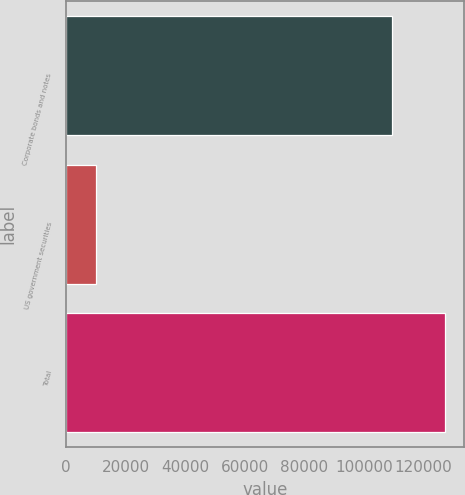Convert chart. <chart><loc_0><loc_0><loc_500><loc_500><bar_chart><fcel>Corporate bonds and notes<fcel>US government securities<fcel>Total<nl><fcel>109613<fcel>9991<fcel>127404<nl></chart> 